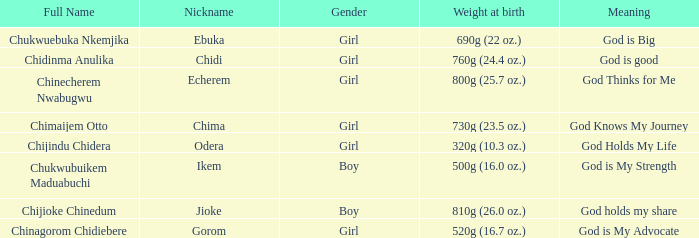What is the alias of the baby who was born weighing 730g (2 Chima. 